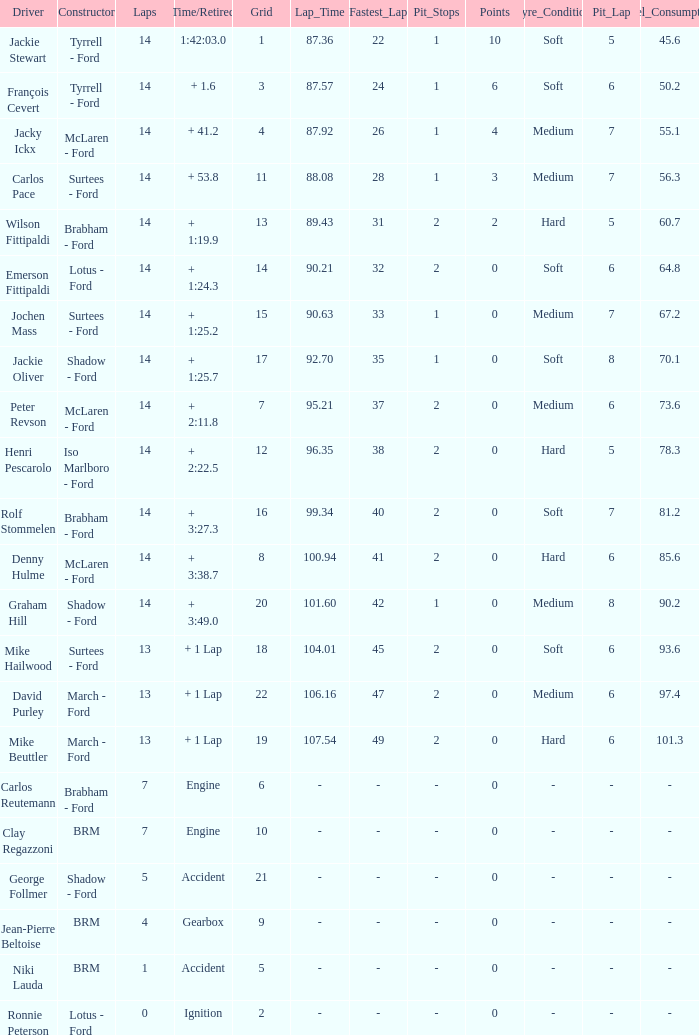What is the low lap total for a grid larger than 16 and has a Time/Retired of + 3:27.3? None. 